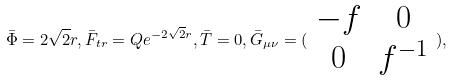Convert formula to latex. <formula><loc_0><loc_0><loc_500><loc_500>\bar { \Phi } = 2 \sqrt { 2 } r , \bar { F } _ { t r } = Q e ^ { - 2 \sqrt { 2 } r } , \bar { T } = 0 , \bar { G } _ { \mu \nu } = ( \begin{array} { c c } - f & 0 \\ 0 & f ^ { - 1 } \end{array} ) ,</formula> 